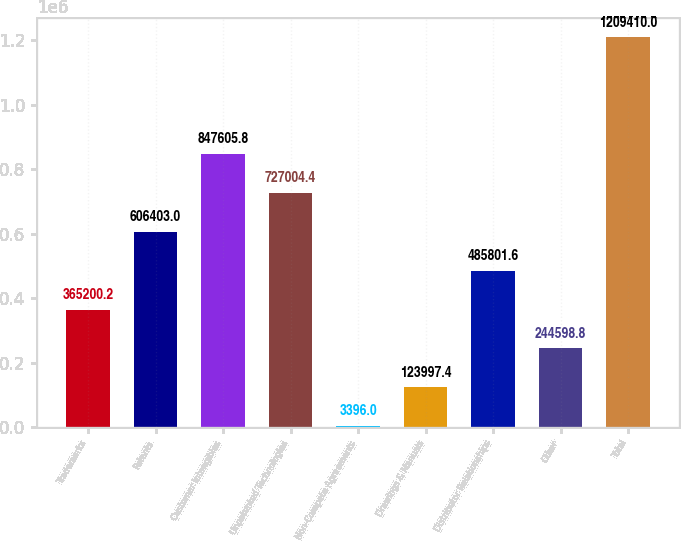Convert chart to OTSL. <chart><loc_0><loc_0><loc_500><loc_500><bar_chart><fcel>Trademarks<fcel>Patents<fcel>Customer Intangibles<fcel>Unpatented Technologies<fcel>Non-Compete Agreements<fcel>Drawings & Manuals<fcel>Distributor Relationships<fcel>Other<fcel>Total<nl><fcel>365200<fcel>606403<fcel>847606<fcel>727004<fcel>3396<fcel>123997<fcel>485802<fcel>244599<fcel>1.20941e+06<nl></chart> 